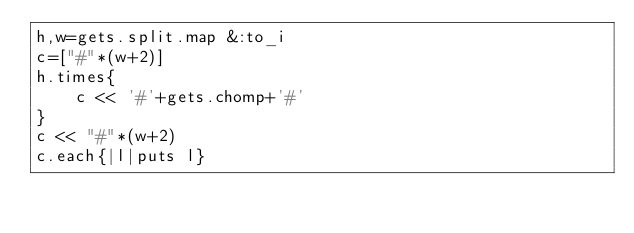<code> <loc_0><loc_0><loc_500><loc_500><_Ruby_>h,w=gets.split.map &:to_i
c=["#"*(w+2)]
h.times{
    c << '#'+gets.chomp+'#'
}
c << "#"*(w+2)
c.each{|l|puts l}</code> 